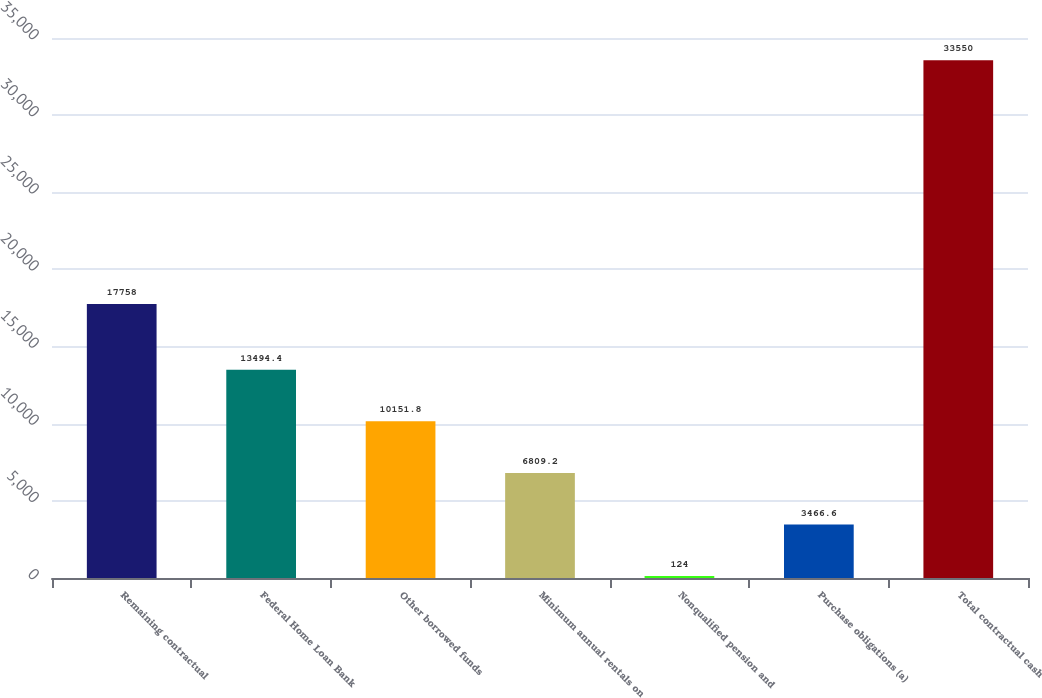Convert chart to OTSL. <chart><loc_0><loc_0><loc_500><loc_500><bar_chart><fcel>Remaining contractual<fcel>Federal Home Loan Bank<fcel>Other borrowed funds<fcel>Minimum annual rentals on<fcel>Nonqualified pension and<fcel>Purchase obligations (a)<fcel>Total contractual cash<nl><fcel>17758<fcel>13494.4<fcel>10151.8<fcel>6809.2<fcel>124<fcel>3466.6<fcel>33550<nl></chart> 